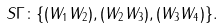Convert formula to latex. <formula><loc_0><loc_0><loc_500><loc_500>S \Gamma \colon \{ ( W _ { 1 } W _ { 2 } ) , ( W _ { 2 } W _ { 3 } ) , ( W _ { 3 } W _ { 4 } ) \} .</formula> 